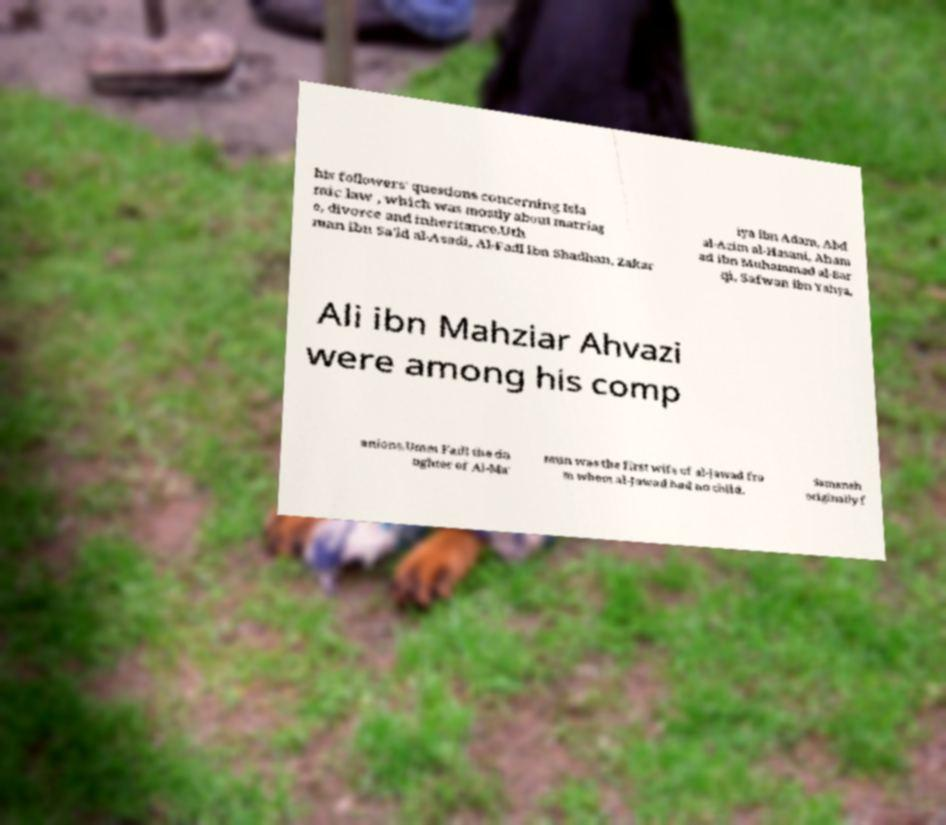Could you extract and type out the text from this image? his followers' questions concerning Isla mic law , which was mostly about marriag e, divorce and inheritance.Uth man ibn Sa'id al-Asadi, Al-Fadl ibn Shadhan, Zakar iya ibn Adam, Abd al-Azim al-Hasani, Aham ad ibn Muhammad al-Bar qi, Safwan ibn Yahya, Ali ibn Mahziar Ahvazi were among his comp anions.Umm Fadl the da ughter of Al-Ma' mun was the first wife of al-Jawad fro m whom al-Jawad had no child. Samaneh originally f 